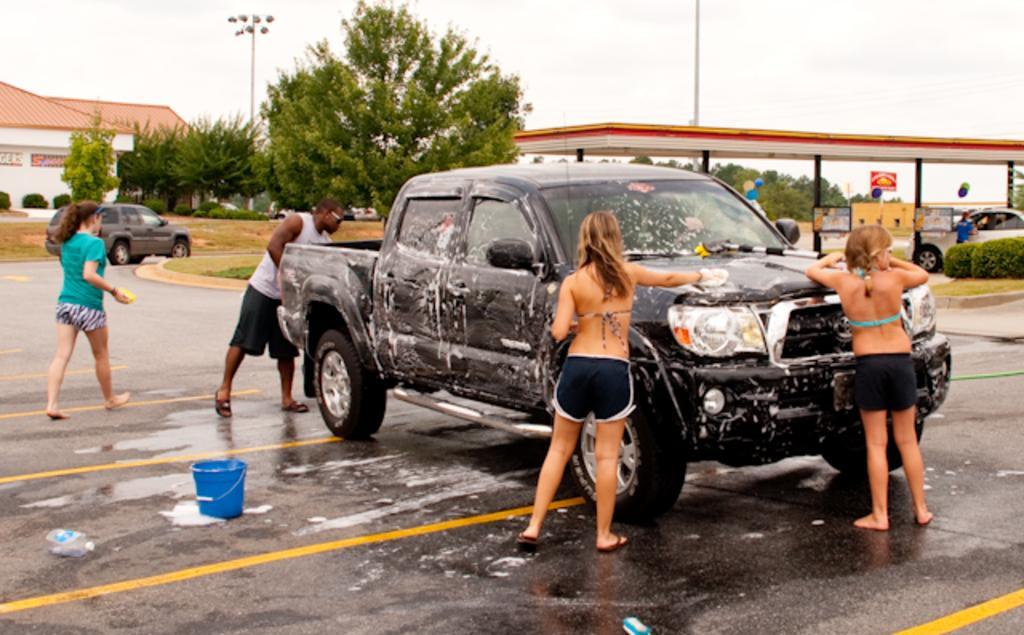Could you give a brief overview of what you see in this image? In this picture I can see the road in front , on which I can see a car and around the car, I can see a man and 3 women standing and I can see a bucket. In the middle of this picture I can see the grass, few cars, plants and a shed. In the background I can see number of trees, 2 poles, a building and the sky. 